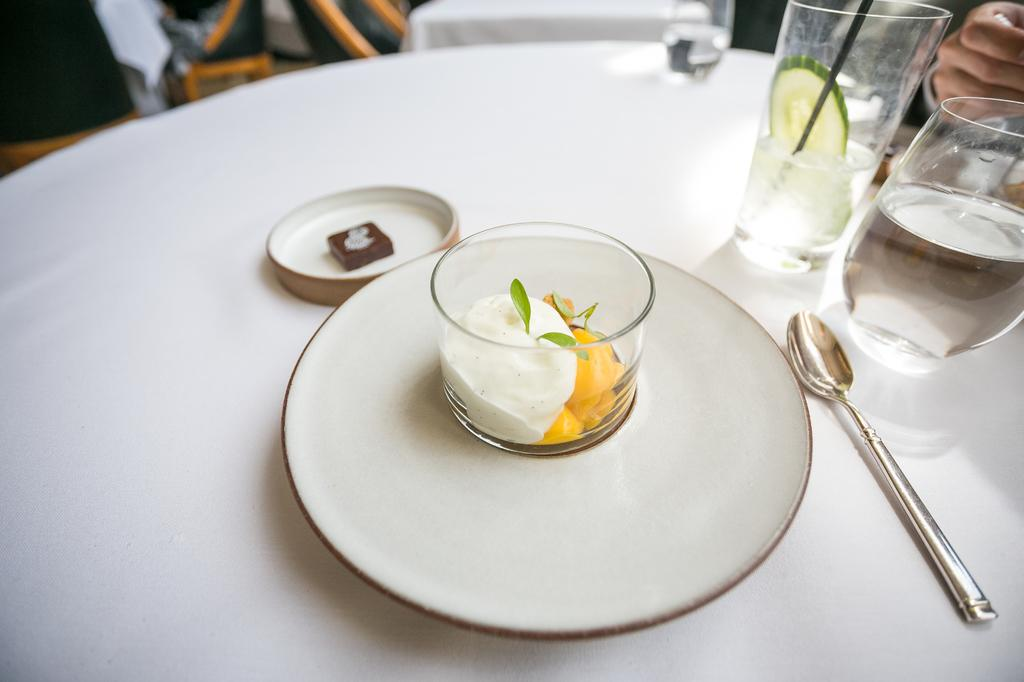What is the person in the image doing? The person is sitting behind the table. What is covering the table in the image? The table is covered with a white cloth. What items can be seen on the table? There is a plate, a spoon, a glass, and food on the table. What type of calculator is visible on the table in the image? There is no calculator present on the table in the image. What thought is the person having while sitting behind the table? The image does not provide any information about the person's thoughts, so it cannot be determined from the image. 